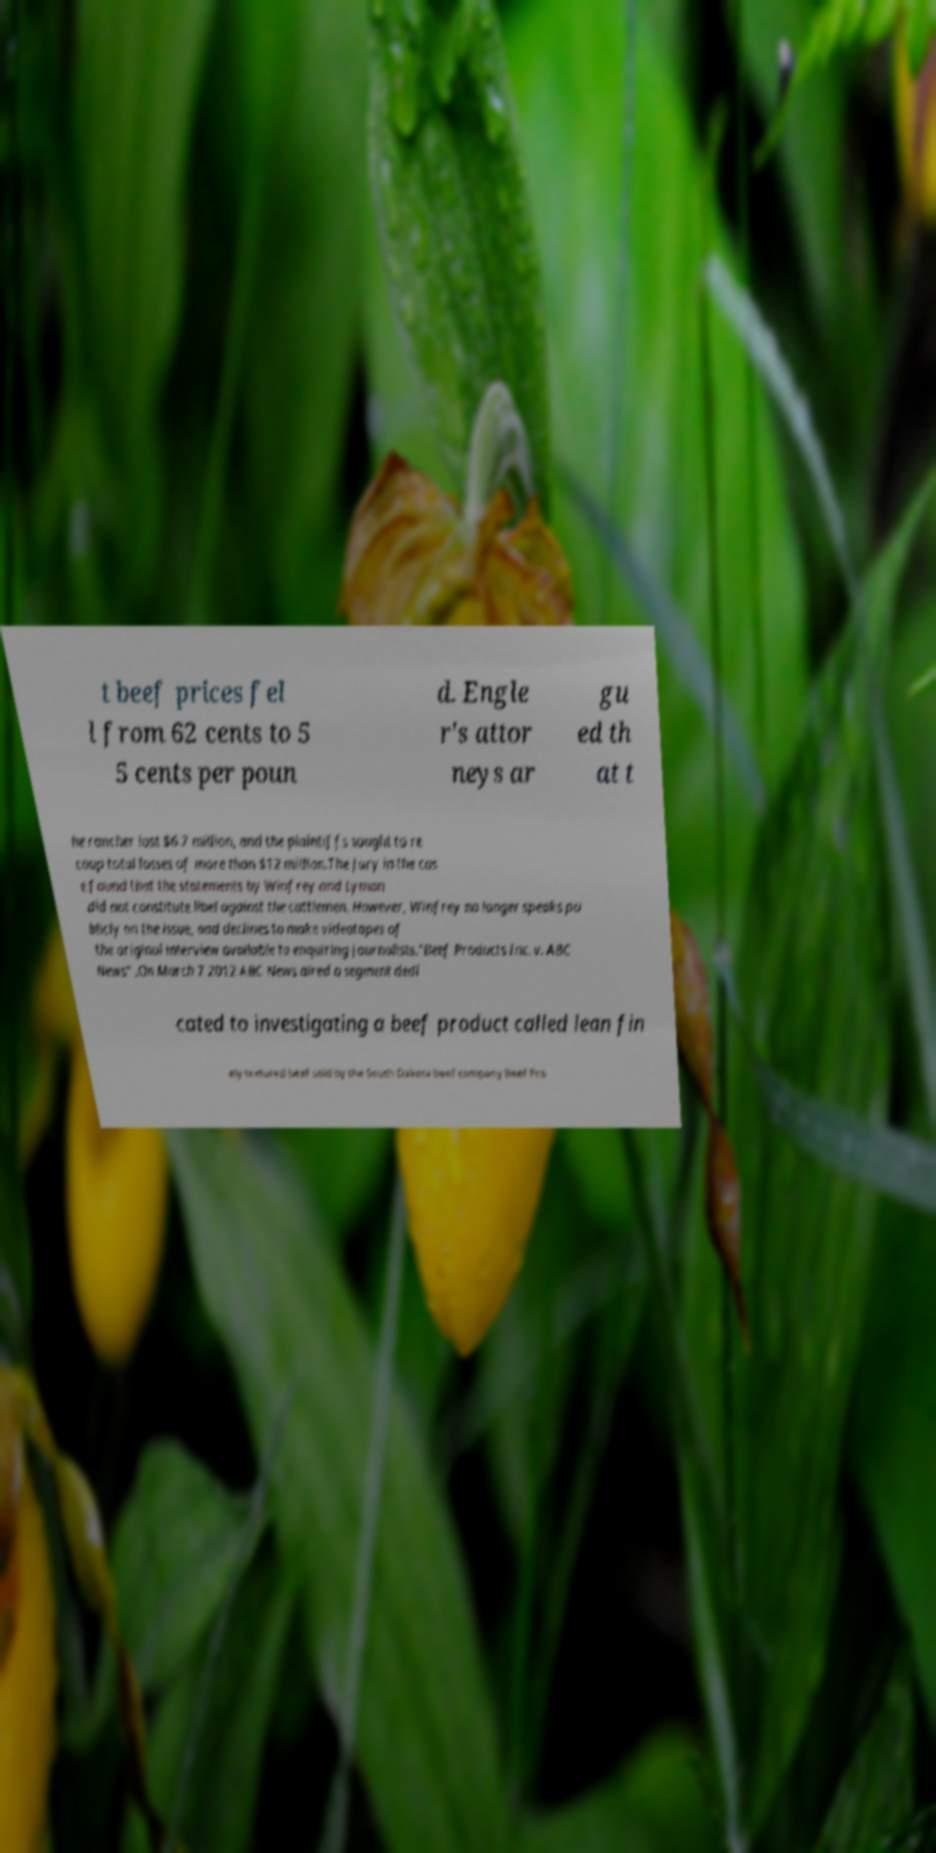Please identify and transcribe the text found in this image. t beef prices fel l from 62 cents to 5 5 cents per poun d. Engle r's attor neys ar gu ed th at t he rancher lost $6.7 million, and the plaintiffs sought to re coup total losses of more than $12 million.The jury in the cas e found that the statements by Winfrey and Lyman did not constitute libel against the cattlemen. However, Winfrey no longer speaks pu blicly on the issue, and declines to make videotapes of the original interview available to enquiring journalists."Beef Products Inc. v. ABC News" .On March 7 2012 ABC News aired a segment dedi cated to investigating a beef product called lean fin ely textured beef sold by the South Dakota beef company Beef Pro 